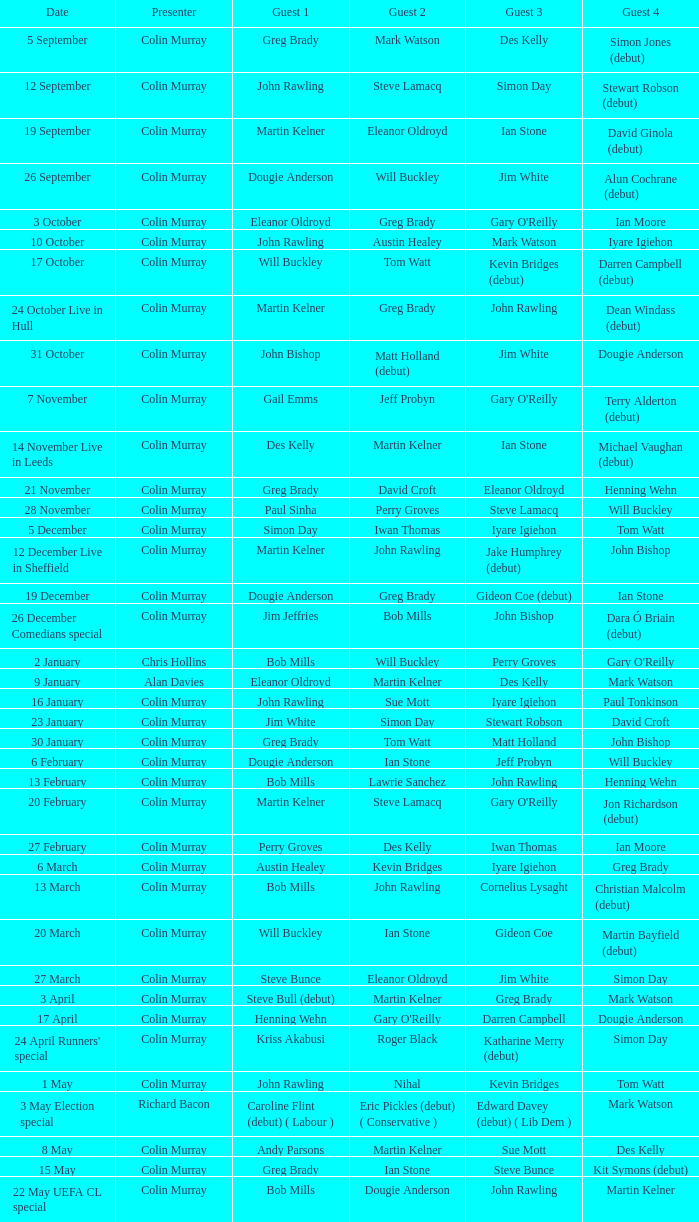How many people are guest 1 on episodes where guest 4 is Des Kelly? 1.0. 